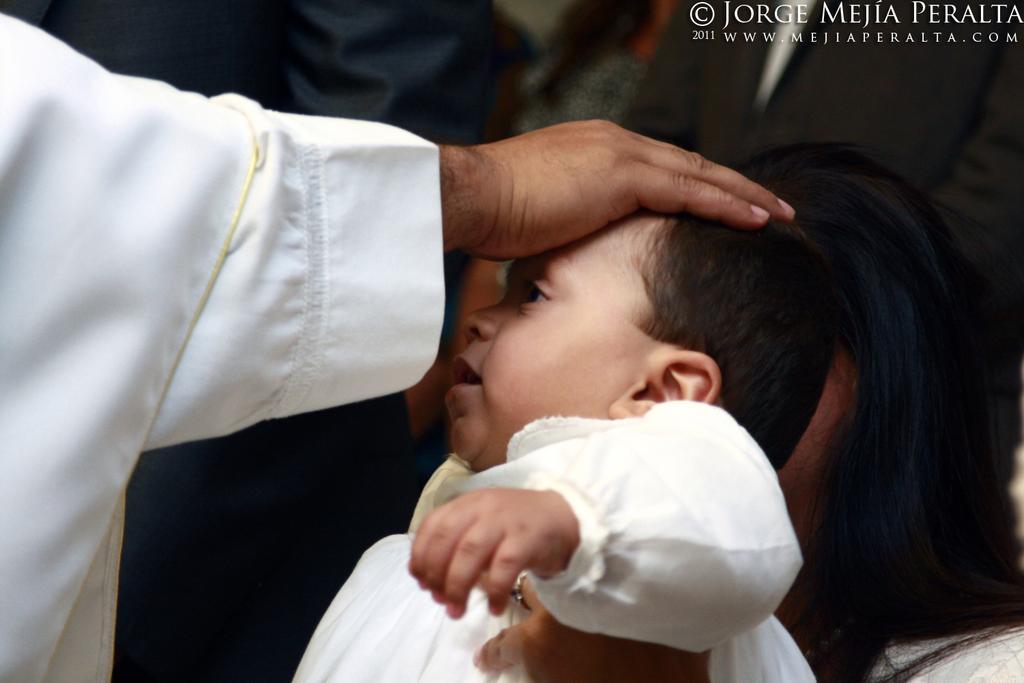Describe this image in one or two sentences. In this image, we can see a person giving blessings to kid. We can see some people and there is a watermark on the top right corner. 